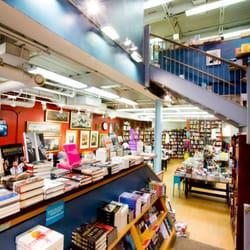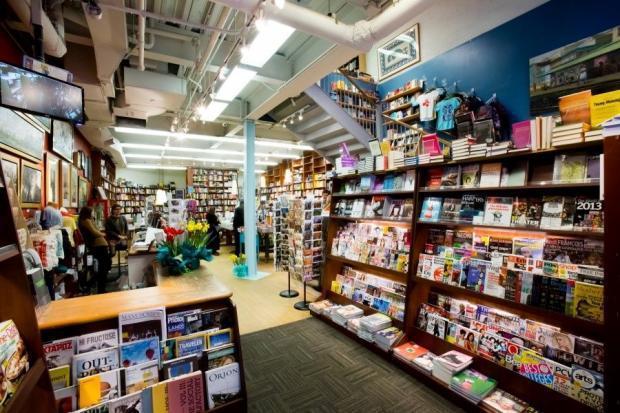The first image is the image on the left, the second image is the image on the right. Considering the images on both sides, is "The right image includes a person standing behind a counter that has three white squares in a row on it, and the wall near the counter is filled almost to the ceiling with books." valid? Answer yes or no. No. 